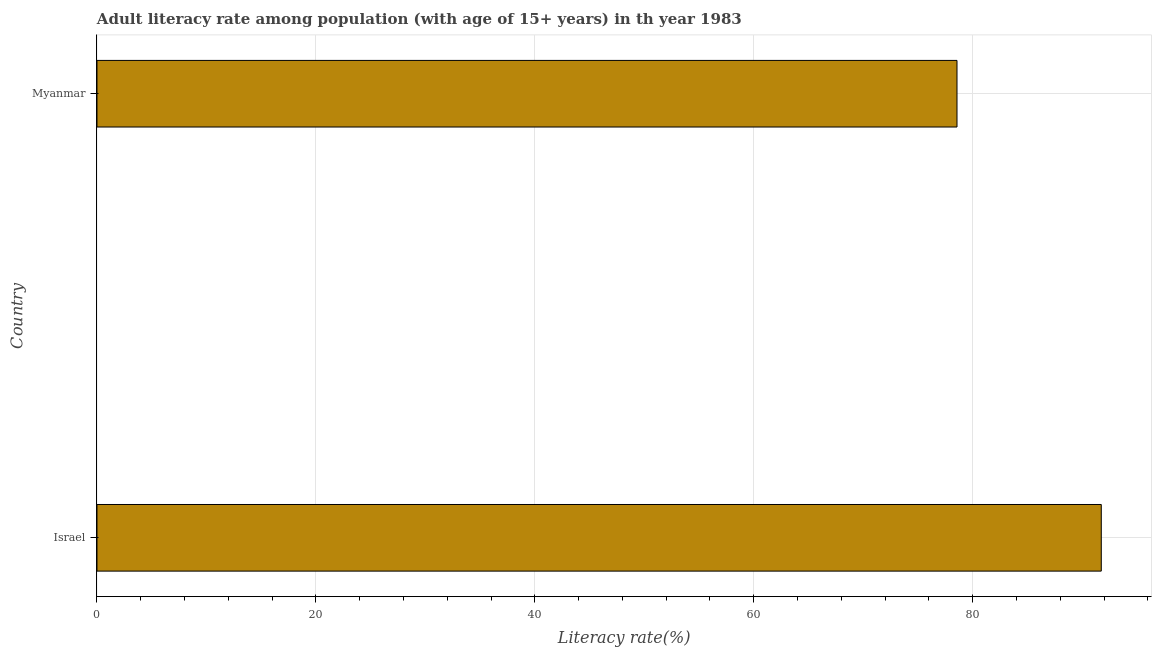Does the graph contain any zero values?
Provide a short and direct response. No. What is the title of the graph?
Offer a terse response. Adult literacy rate among population (with age of 15+ years) in th year 1983. What is the label or title of the X-axis?
Offer a very short reply. Literacy rate(%). What is the label or title of the Y-axis?
Give a very brief answer. Country. What is the adult literacy rate in Israel?
Provide a succinct answer. 91.75. Across all countries, what is the maximum adult literacy rate?
Your response must be concise. 91.75. Across all countries, what is the minimum adult literacy rate?
Offer a very short reply. 78.57. In which country was the adult literacy rate maximum?
Keep it short and to the point. Israel. In which country was the adult literacy rate minimum?
Ensure brevity in your answer.  Myanmar. What is the sum of the adult literacy rate?
Your answer should be compact. 170.32. What is the difference between the adult literacy rate in Israel and Myanmar?
Your answer should be very brief. 13.18. What is the average adult literacy rate per country?
Make the answer very short. 85.16. What is the median adult literacy rate?
Your response must be concise. 85.16. In how many countries, is the adult literacy rate greater than 36 %?
Make the answer very short. 2. What is the ratio of the adult literacy rate in Israel to that in Myanmar?
Offer a terse response. 1.17. How many countries are there in the graph?
Provide a succinct answer. 2. What is the difference between two consecutive major ticks on the X-axis?
Provide a short and direct response. 20. What is the Literacy rate(%) in Israel?
Ensure brevity in your answer.  91.75. What is the Literacy rate(%) of Myanmar?
Your answer should be very brief. 78.57. What is the difference between the Literacy rate(%) in Israel and Myanmar?
Offer a terse response. 13.18. What is the ratio of the Literacy rate(%) in Israel to that in Myanmar?
Ensure brevity in your answer.  1.17. 